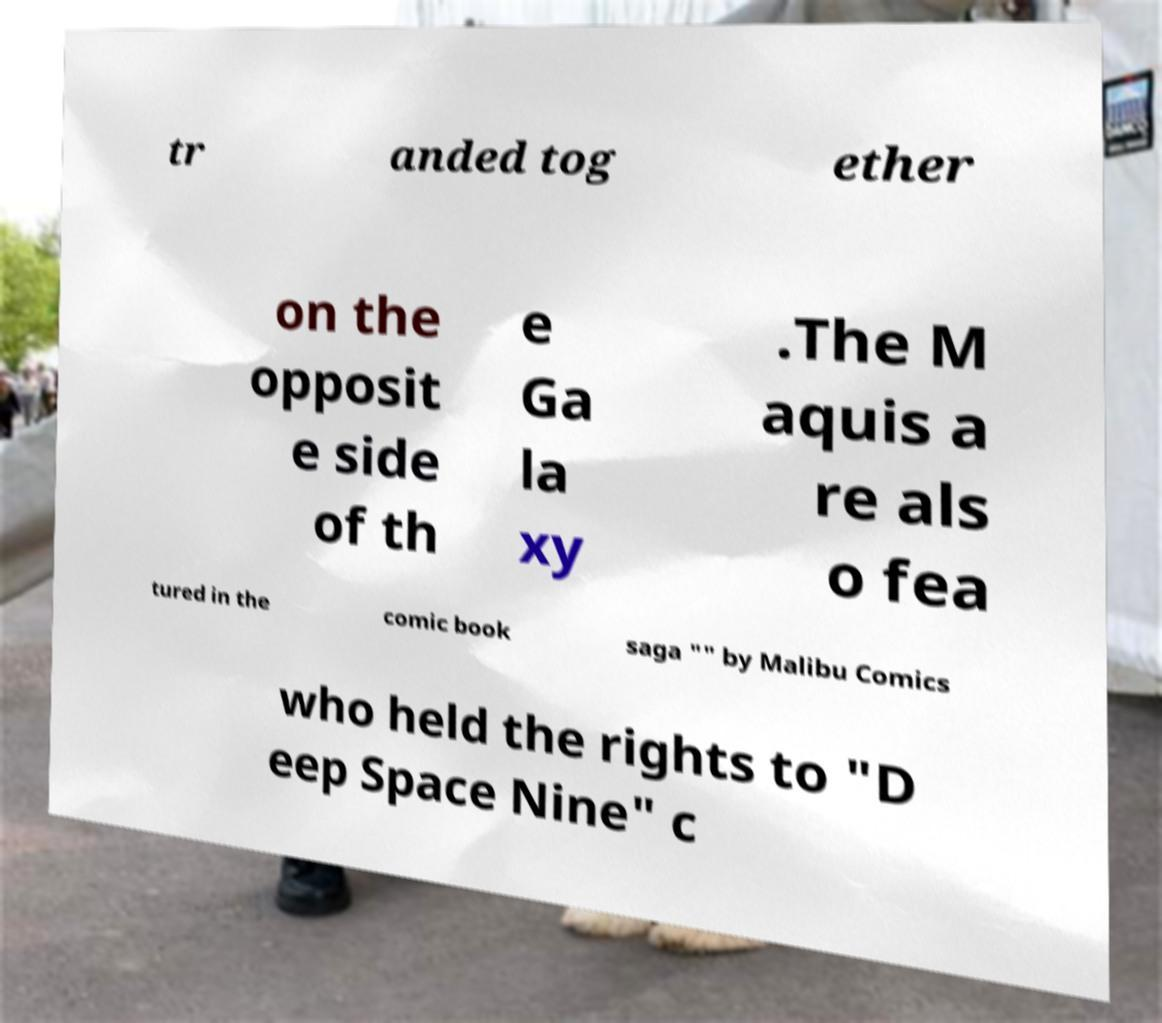Could you assist in decoding the text presented in this image and type it out clearly? tr anded tog ether on the opposit e side of th e Ga la xy .The M aquis a re als o fea tured in the comic book saga "" by Malibu Comics who held the rights to "D eep Space Nine" c 